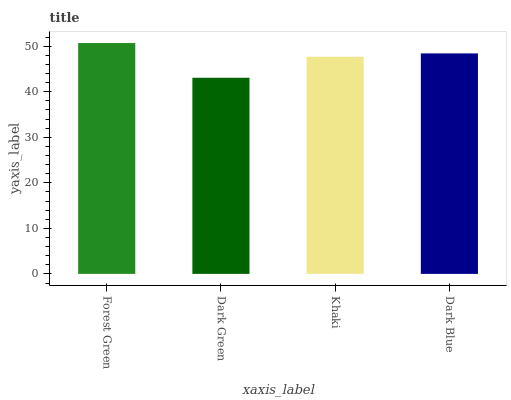Is Dark Green the minimum?
Answer yes or no. Yes. Is Forest Green the maximum?
Answer yes or no. Yes. Is Khaki the minimum?
Answer yes or no. No. Is Khaki the maximum?
Answer yes or no. No. Is Khaki greater than Dark Green?
Answer yes or no. Yes. Is Dark Green less than Khaki?
Answer yes or no. Yes. Is Dark Green greater than Khaki?
Answer yes or no. No. Is Khaki less than Dark Green?
Answer yes or no. No. Is Dark Blue the high median?
Answer yes or no. Yes. Is Khaki the low median?
Answer yes or no. Yes. Is Khaki the high median?
Answer yes or no. No. Is Dark Blue the low median?
Answer yes or no. No. 